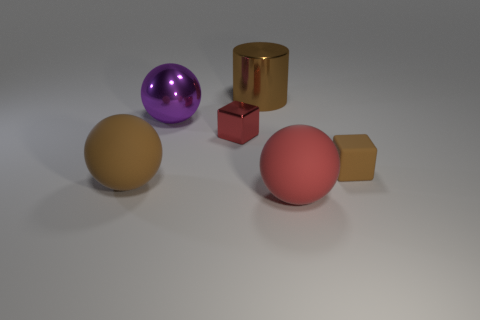Add 4 small brown rubber cubes. How many objects exist? 10 Subtract all cylinders. How many objects are left? 5 Add 2 brown rubber things. How many brown rubber things are left? 4 Add 6 purple metal things. How many purple metal things exist? 7 Subtract 0 cyan spheres. How many objects are left? 6 Subtract all big brown metallic cylinders. Subtract all tiny red metal blocks. How many objects are left? 4 